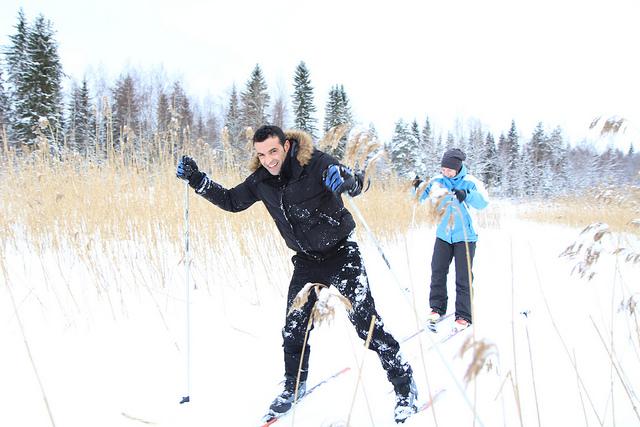Are the people cold?
Give a very brief answer. Yes. How many women are in this picture?
Be succinct. 1. What kind of shoes is the man wearing?
Write a very short answer. Ski boots. What are they doing?
Quick response, please. Skiing. 